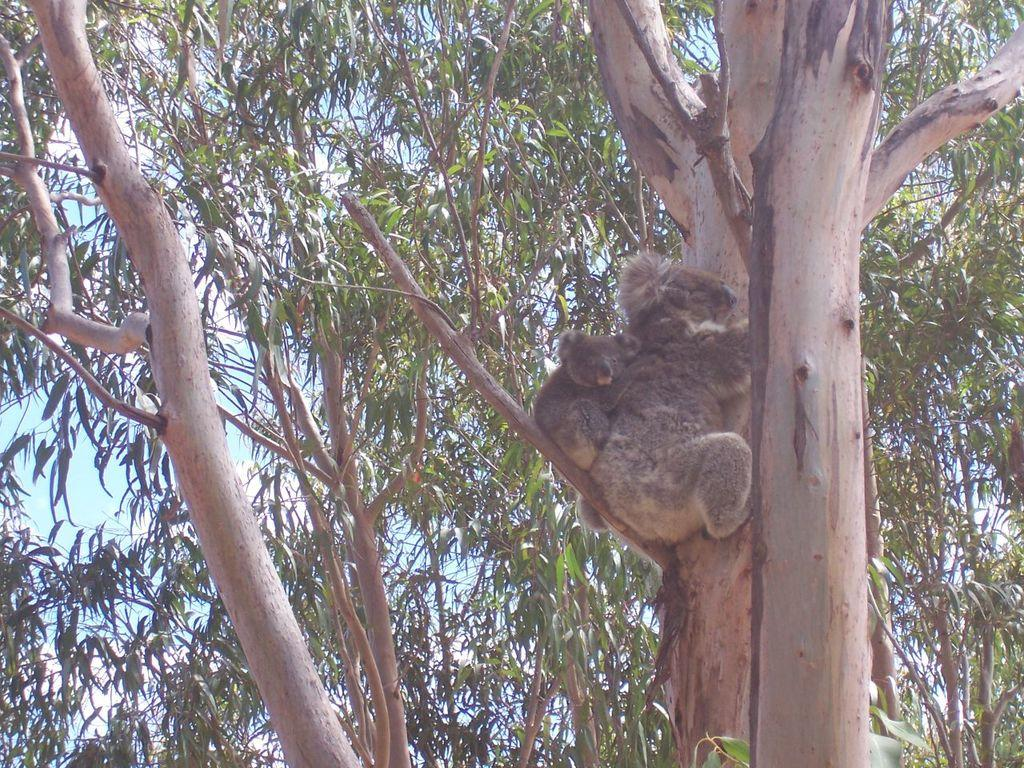How many bears are in the image? There are two bears in the image. What are the bears doing in the image? The bears are sitting on a branch of a tree. What can be seen in the background of the image? There are trees in the background of the image. What type of flag is visible on the bears' voyage in the image? There is no flag or voyage present in the image; it features two bears sitting on a tree branch. How many screws can be seen holding the bears to the tree in the image? There are no screws visible in the image; the bears are sitting on a branch of a tree. 